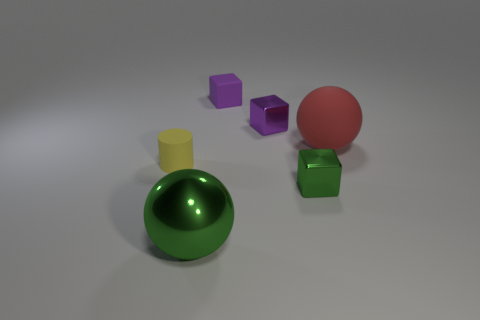Add 2 large yellow things. How many objects exist? 8 Subtract all spheres. How many objects are left? 4 Add 2 small green blocks. How many small green blocks are left? 3 Add 4 big rubber things. How many big rubber things exist? 5 Subtract 0 purple balls. How many objects are left? 6 Subtract all tiny shiny blocks. Subtract all big blue metallic balls. How many objects are left? 4 